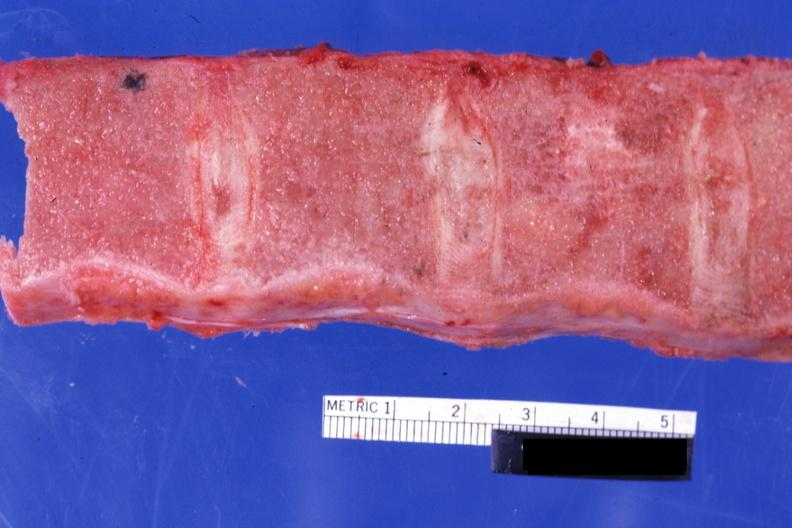s hematologic present?
Answer the question using a single word or phrase. Yes 